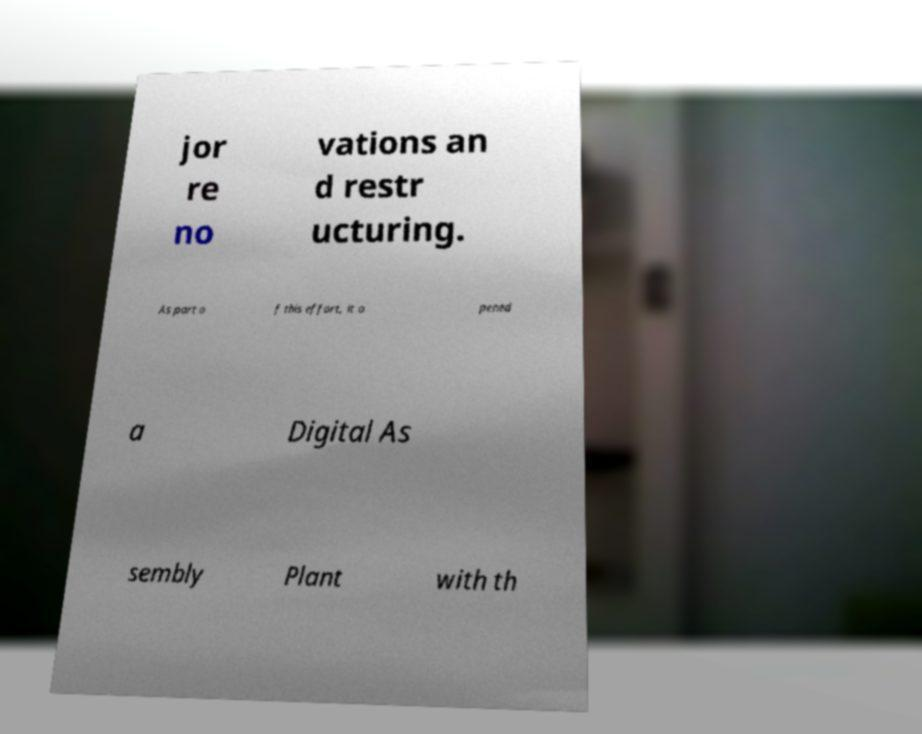Could you assist in decoding the text presented in this image and type it out clearly? jor re no vations an d restr ucturing. As part o f this effort, it o pened a Digital As sembly Plant with th 